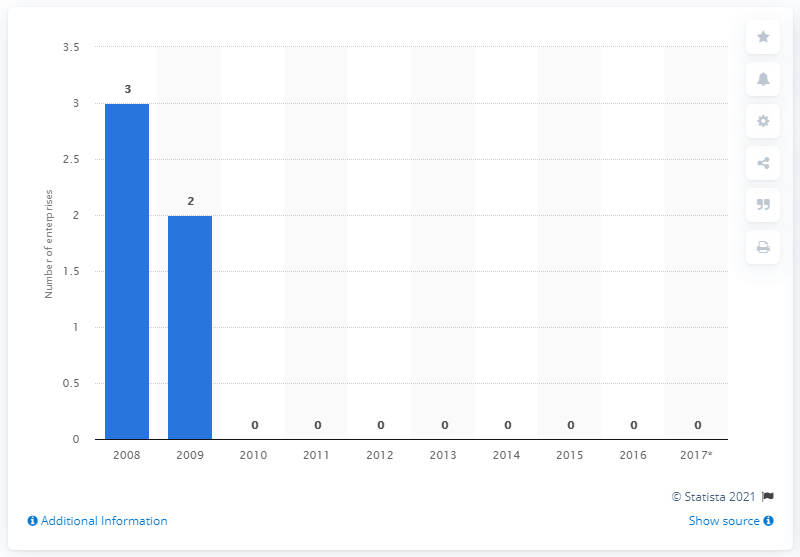List a handful of essential elements in this visual. In 2014, there were no enterprises mining hard coal in Latvia. 